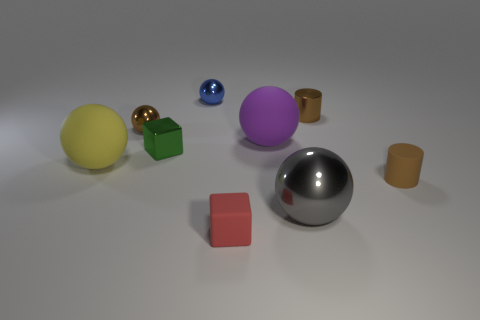Subtract all purple spheres. How many spheres are left? 4 Subtract all brown metallic spheres. How many spheres are left? 4 Subtract all green balls. Subtract all cyan cubes. How many balls are left? 5 Subtract all cubes. How many objects are left? 7 Add 1 brown metal cylinders. How many brown metal cylinders exist? 2 Subtract 1 brown balls. How many objects are left? 8 Subtract all gray balls. Subtract all big purple spheres. How many objects are left? 7 Add 5 gray things. How many gray things are left? 6 